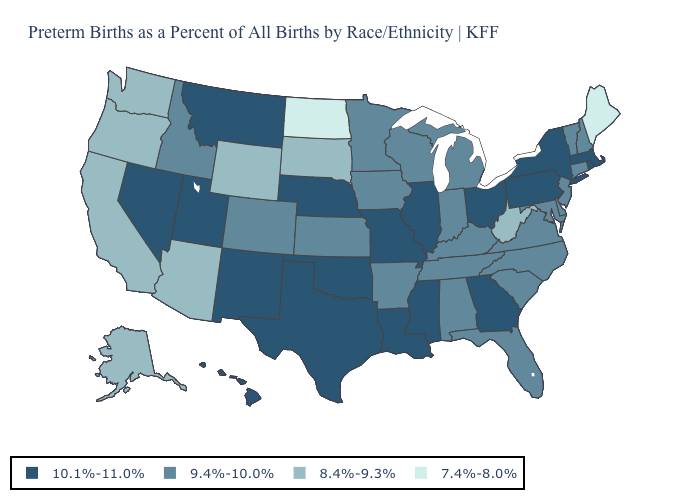Does West Virginia have the lowest value in the USA?
Keep it brief. No. What is the value of South Carolina?
Short answer required. 9.4%-10.0%. Among the states that border New York , which have the highest value?
Keep it brief. Massachusetts, Pennsylvania. Among the states that border Indiana , does Ohio have the lowest value?
Quick response, please. No. Name the states that have a value in the range 9.4%-10.0%?
Give a very brief answer. Alabama, Arkansas, Colorado, Connecticut, Delaware, Florida, Idaho, Indiana, Iowa, Kansas, Kentucky, Maryland, Michigan, Minnesota, New Hampshire, New Jersey, North Carolina, South Carolina, Tennessee, Vermont, Virginia, Wisconsin. Name the states that have a value in the range 10.1%-11.0%?
Keep it brief. Georgia, Hawaii, Illinois, Louisiana, Massachusetts, Mississippi, Missouri, Montana, Nebraska, Nevada, New Mexico, New York, Ohio, Oklahoma, Pennsylvania, Rhode Island, Texas, Utah. Does the map have missing data?
Write a very short answer. No. What is the value of Washington?
Keep it brief. 8.4%-9.3%. Does Ohio have the lowest value in the MidWest?
Be succinct. No. Does North Dakota have the lowest value in the USA?
Give a very brief answer. Yes. Which states hav the highest value in the South?
Keep it brief. Georgia, Louisiana, Mississippi, Oklahoma, Texas. Does Virginia have the highest value in the South?
Write a very short answer. No. Does the map have missing data?
Answer briefly. No. Name the states that have a value in the range 7.4%-8.0%?
Be succinct. Maine, North Dakota. 